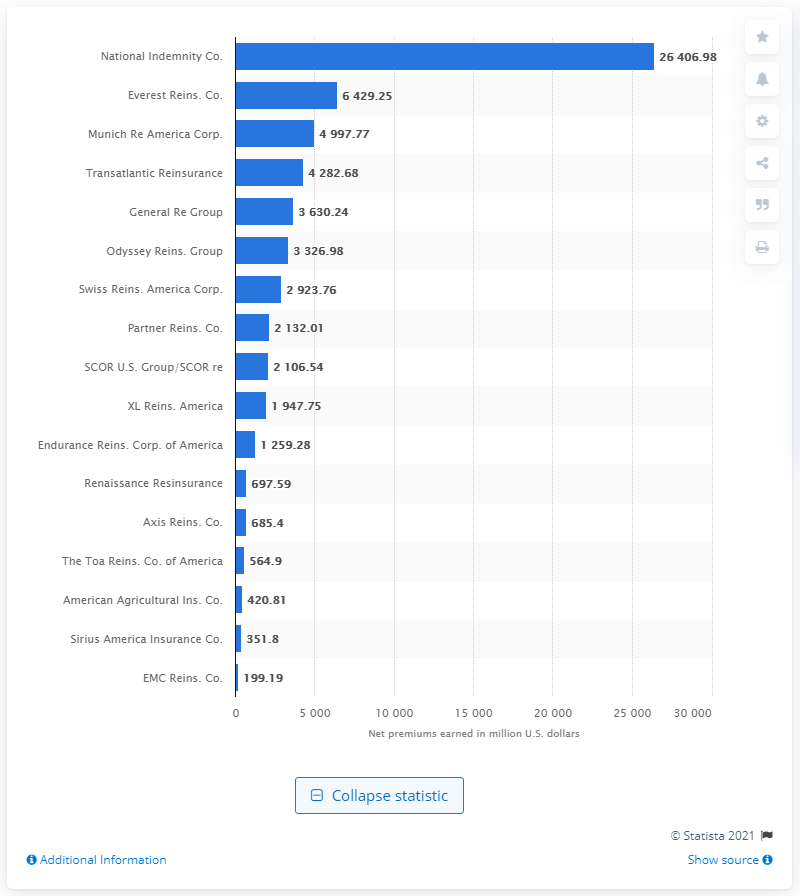Mention a couple of crucial points in this snapshot. In 2020, National Indemnity Company's net premiums amounted to a total of $26,406.98. 